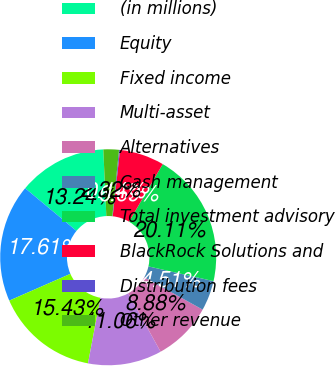Convert chart. <chart><loc_0><loc_0><loc_500><loc_500><pie_chart><fcel>(in millions)<fcel>Equity<fcel>Fixed income<fcel>Multi-asset<fcel>Alternatives<fcel>Cash management<fcel>Total investment advisory<fcel>BlackRock Solutions and<fcel>Distribution fees<fcel>Other revenue<nl><fcel>13.24%<fcel>17.61%<fcel>15.43%<fcel>11.06%<fcel>8.88%<fcel>4.51%<fcel>20.11%<fcel>6.69%<fcel>0.14%<fcel>2.32%<nl></chart> 